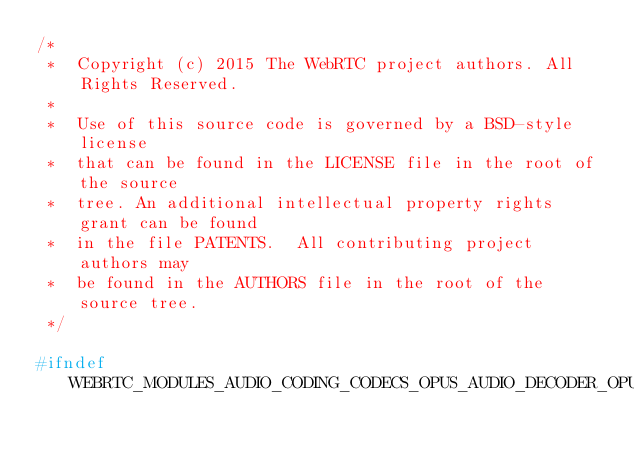<code> <loc_0><loc_0><loc_500><loc_500><_C_>/*
 *  Copyright (c) 2015 The WebRTC project authors. All Rights Reserved.
 *
 *  Use of this source code is governed by a BSD-style license
 *  that can be found in the LICENSE file in the root of the source
 *  tree. An additional intellectual property rights grant can be found
 *  in the file PATENTS.  All contributing project authors may
 *  be found in the AUTHORS file in the root of the source tree.
 */

#ifndef WEBRTC_MODULES_AUDIO_CODING_CODECS_OPUS_AUDIO_DECODER_OPUS_H_</code> 